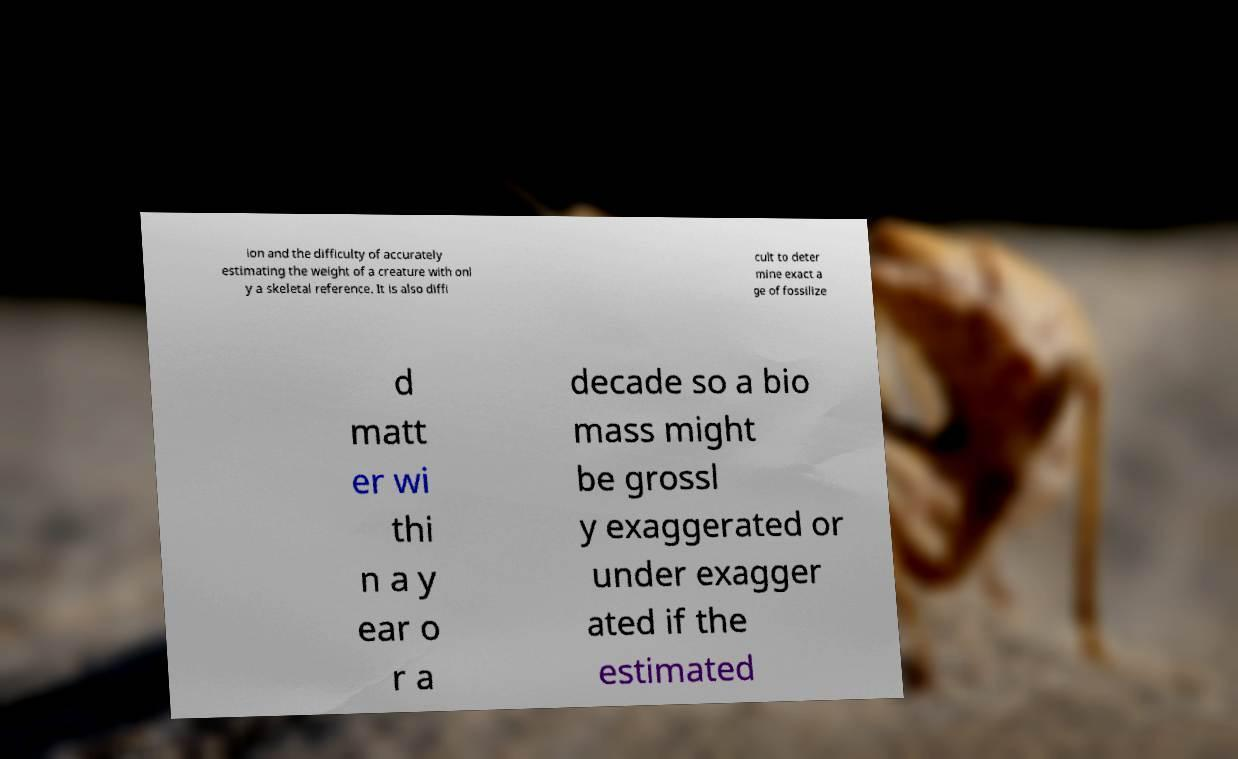There's text embedded in this image that I need extracted. Can you transcribe it verbatim? ion and the difficulty of accurately estimating the weight of a creature with onl y a skeletal reference. It is also diffi cult to deter mine exact a ge of fossilize d matt er wi thi n a y ear o r a decade so a bio mass might be grossl y exaggerated or under exagger ated if the estimated 